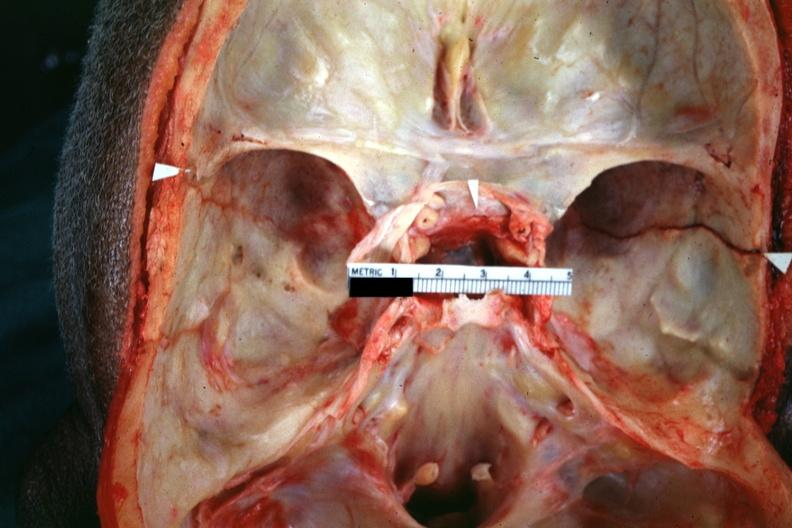what is present?
Answer the question using a single word or phrase. Bone 